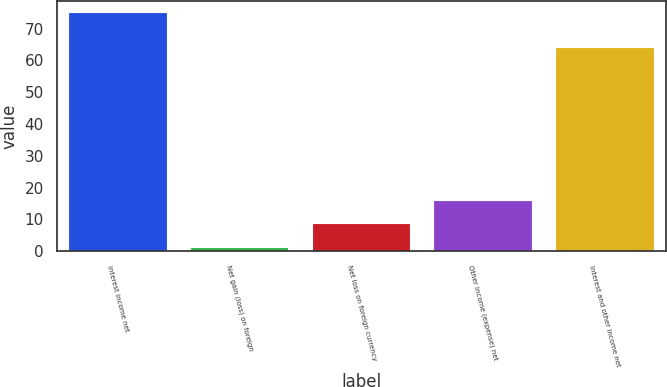Convert chart to OTSL. <chart><loc_0><loc_0><loc_500><loc_500><bar_chart><fcel>Interest income net<fcel>Net gain (loss) on foreign<fcel>Net loss on foreign currency<fcel>Other income (expense) net<fcel>Interest and other income net<nl><fcel>75<fcel>1<fcel>8.4<fcel>15.8<fcel>64<nl></chart> 